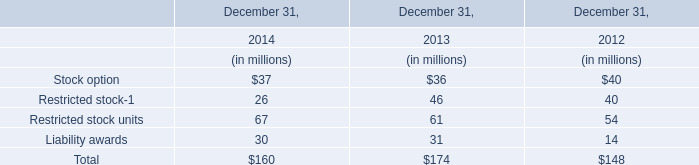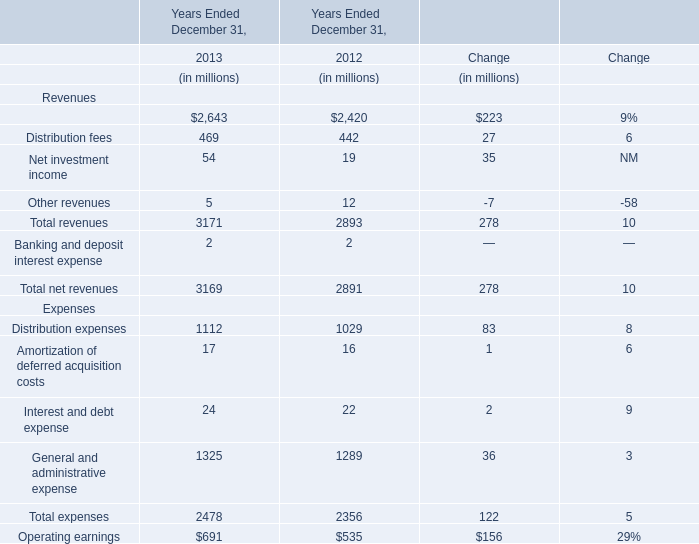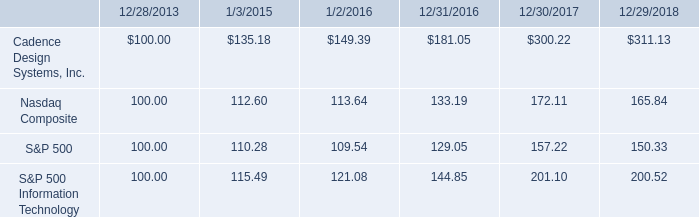what was the percentage cumulative 5-year total stockholder return for cadence design systems inc . for the period ending 12/29/2018? 
Computations: ((311.13 - 100) / 100)
Answer: 2.1113. 